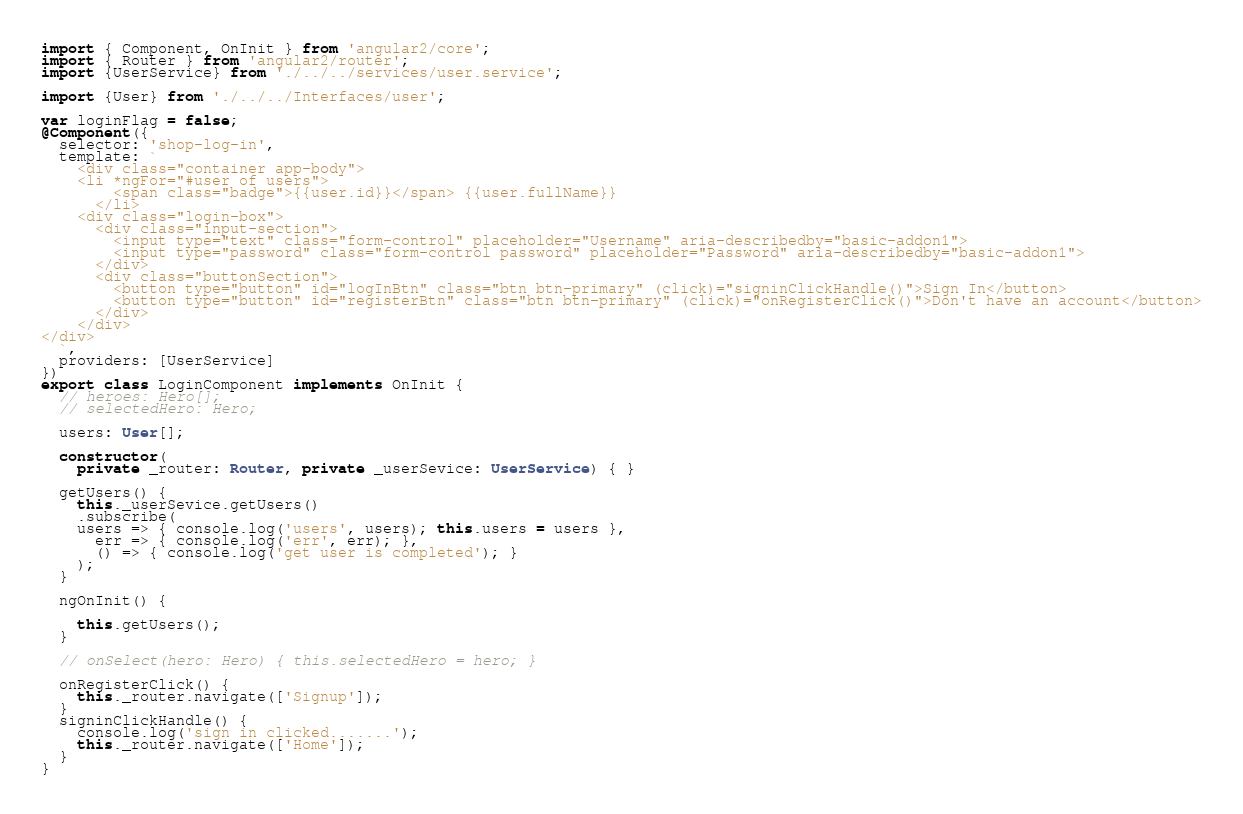<code> <loc_0><loc_0><loc_500><loc_500><_TypeScript_>import { Component, OnInit } from 'angular2/core';
import { Router } from 'angular2/router';
import {UserService} from './../../services/user.service';

import {User} from './../../Interfaces/user';

var loginFlag = false;
@Component({
  selector: 'shop-log-in',
  template: `
    <div class="container app-body">
    <li *ngFor="#user of users">
        <span class="badge">{{user.id}}</span> {{user.fullName}}
      </li>
    <div class="login-box">
      <div class="input-section">
        <input type="text" class="form-control" placeholder="Username" aria-describedby="basic-addon1">
        <input type="password" class="form-control password" placeholder="Password" aria-describedby="basic-addon1">
      </div>
      <div class="buttonSection">
        <button type="button" id="logInBtn" class="btn btn-primary" (click)="signinClickHandle()">Sign In</button>
        <button type="button" id="registerBtn" class="btn btn-primary" (click)="onRegisterClick()">Don't have an account</button>
      </div>
    </div>
</div>
  `,
  providers: [UserService]
})
export class LoginComponent implements OnInit {
  // heroes: Hero[];
  // selectedHero: Hero;

  users: User[];

  constructor(
    private _router: Router, private _userSevice: UserService) { }

  getUsers() {
    this._userSevice.getUsers()
    .subscribe(
    users => { console.log('users', users); this.users = users },
      err => { console.log('err', err); },
      () => { console.log('get user is completed'); }
    );
  }

  ngOnInit() {
   
    this.getUsers();
  }

  // onSelect(hero: Hero) { this.selectedHero = hero; }

  onRegisterClick() {
    this._router.navigate(['Signup']);
  }
  signinClickHandle() {
    console.log('sign in clicked.......');
    this._router.navigate(['Home']);
  }
}
</code> 